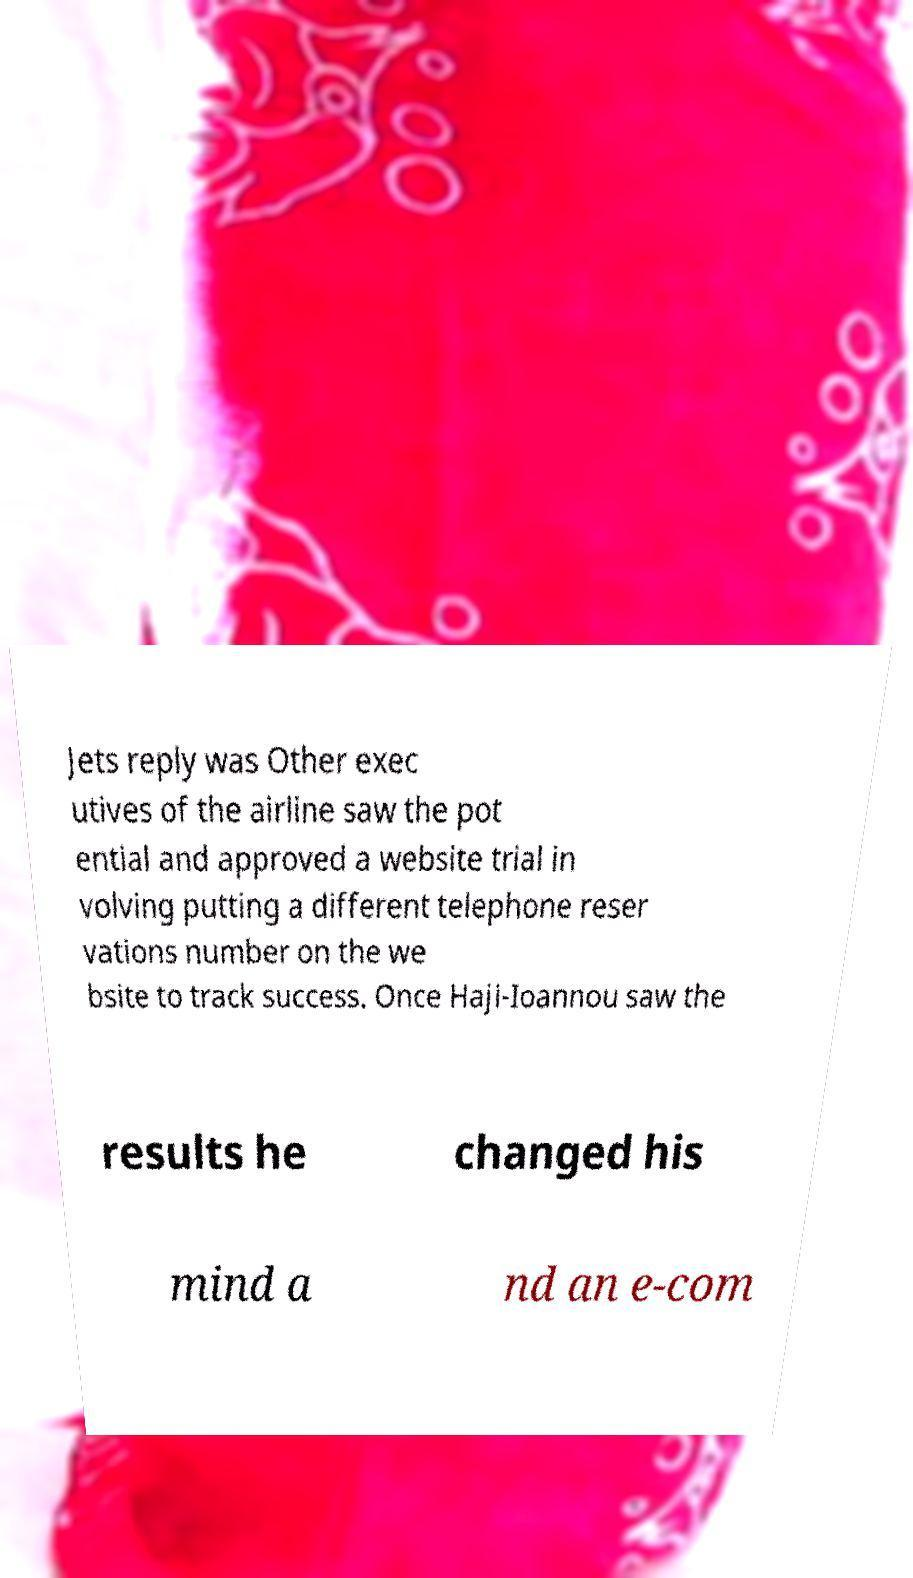There's text embedded in this image that I need extracted. Can you transcribe it verbatim? Jets reply was Other exec utives of the airline saw the pot ential and approved a website trial in volving putting a different telephone reser vations number on the we bsite to track success. Once Haji-Ioannou saw the results he changed his mind a nd an e-com 